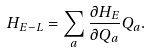Convert formula to latex. <formula><loc_0><loc_0><loc_500><loc_500>H _ { E - L } = \sum _ { a } \frac { \partial H _ { E } } { \partial Q _ { a } } Q _ { a } .</formula> 